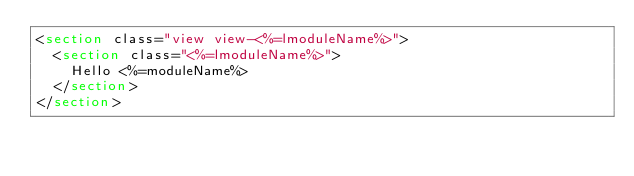<code> <loc_0><loc_0><loc_500><loc_500><_HTML_><section class="view view-<%=lmoduleName%>">
  <section class="<%=lmoduleName%>">
    Hello <%=moduleName%>
  </section>
</section>
</code> 